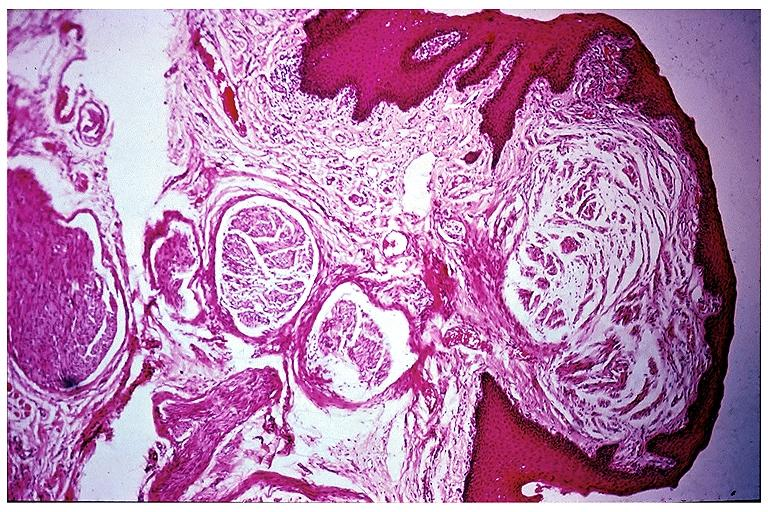does this image show multiple endocrine neoplasia type ii b-neuroma?
Answer the question using a single word or phrase. Yes 